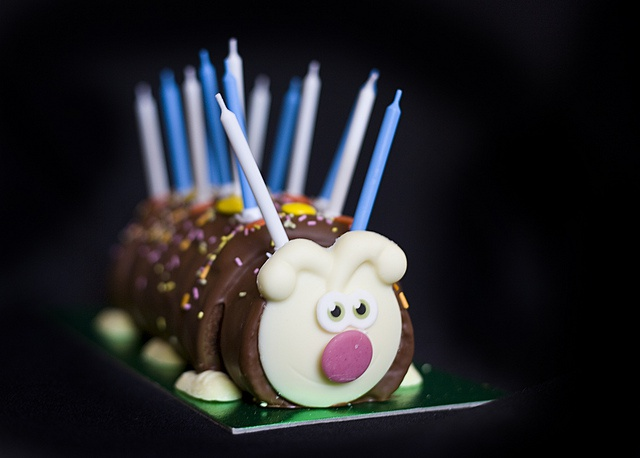Describe the objects in this image and their specific colors. I can see a cake in black, lightgray, and maroon tones in this image. 